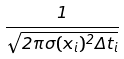<formula> <loc_0><loc_0><loc_500><loc_500>\frac { 1 } { \sqrt { 2 \pi \sigma ( x _ { i } ) ^ { 2 } \Delta t _ { i } } }</formula> 